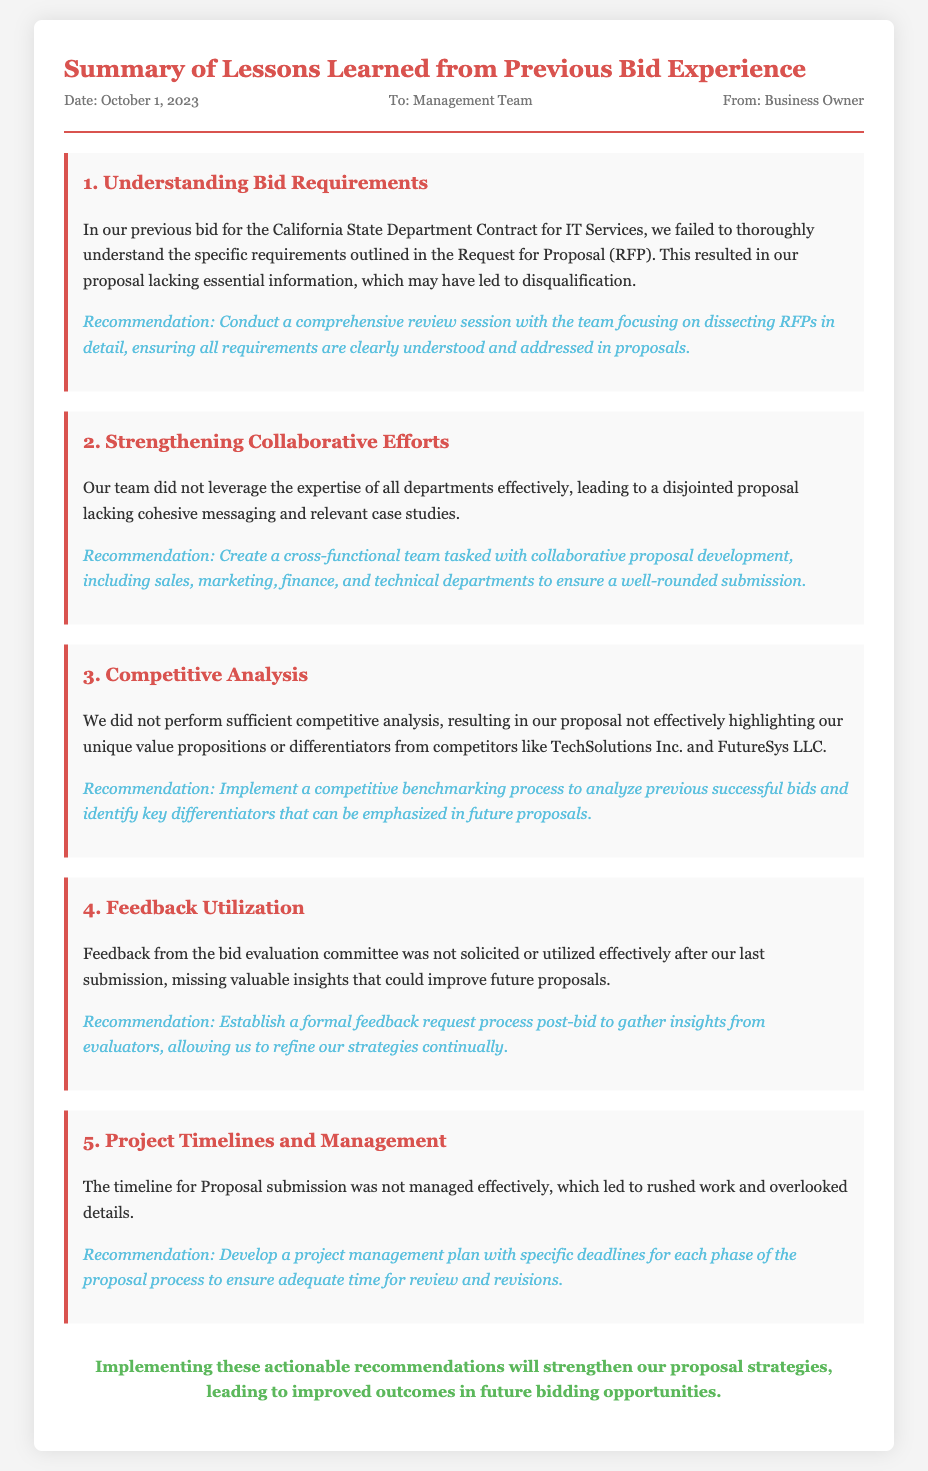What is the date of the memo? The date is mentioned at the top of the memo under the meta section.
Answer: October 1, 2023 Who is the memo addressed to? The recipient of the memo is stated in the meta section.
Answer: Management Team What was the first lesson learned from the previous bid experience? The first lesson is highlighted in the document under the lesson section.
Answer: Understanding Bid Requirements What is the recommendation associated with competitive analysis? The recommendation is included in the competitive analysis lesson section.
Answer: Implement a competitive benchmarking process What were the project management issues identified? The issues related to project management are found in the corresponding lesson section.
Answer: The timeline for Proposal submission was not managed effectively How many lessons learned are discussed in the memo? The number of lessons can be counted from the respective sections in the document.
Answer: Five What is the conclusion of the memo? The conclusion summarizes the action items for future proposals, located at the end of the document.
Answer: Implementing these actionable recommendations will strengthen our proposal strategies 